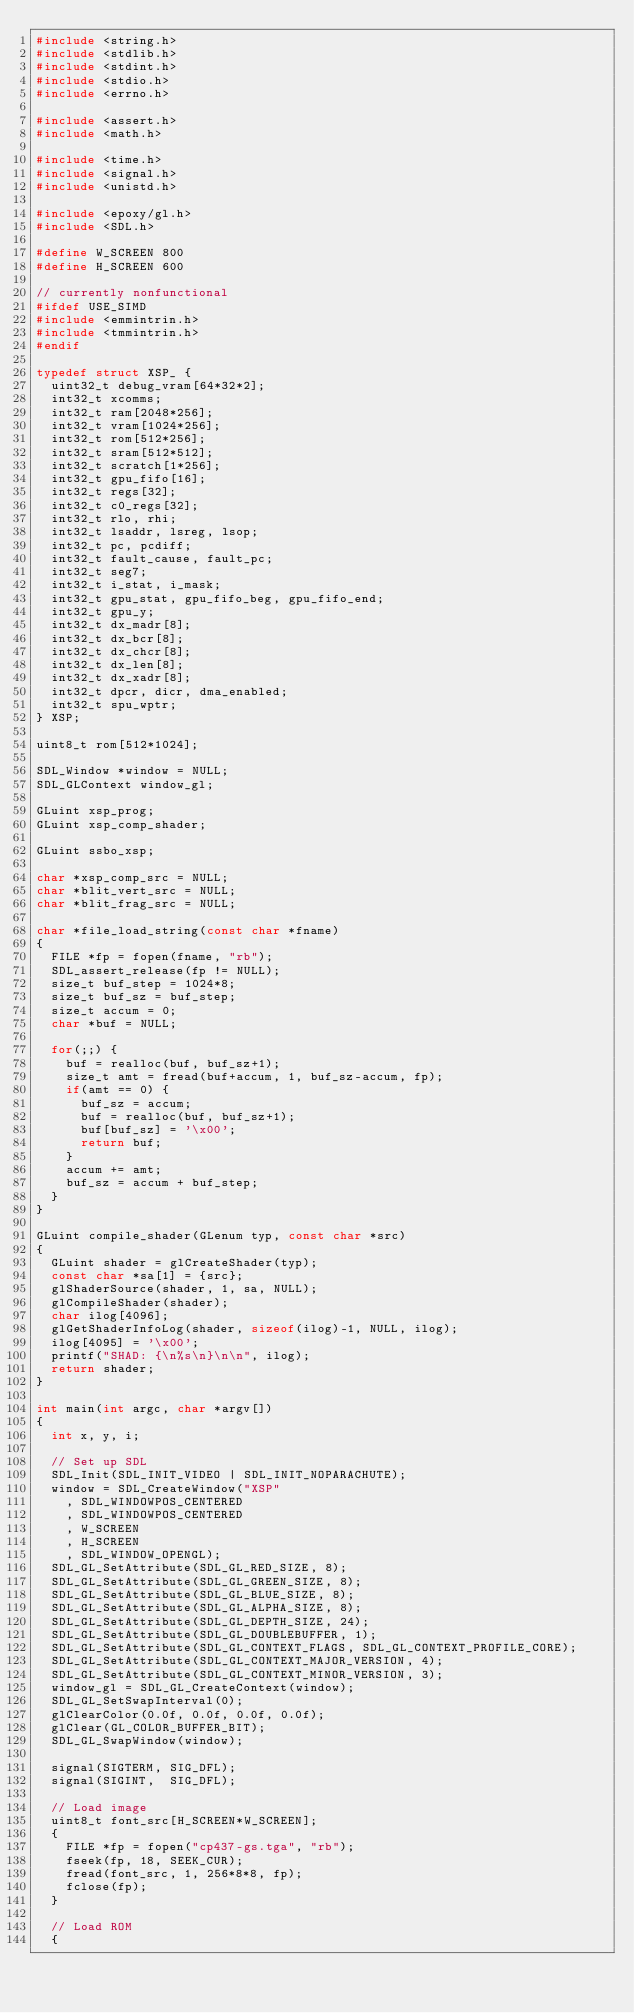Convert code to text. <code><loc_0><loc_0><loc_500><loc_500><_C_>#include <string.h>
#include <stdlib.h>
#include <stdint.h>
#include <stdio.h>
#include <errno.h>

#include <assert.h>
#include <math.h>

#include <time.h>
#include <signal.h>
#include <unistd.h>

#include <epoxy/gl.h>
#include <SDL.h>

#define W_SCREEN 800
#define H_SCREEN 600

// currently nonfunctional
#ifdef USE_SIMD
#include <emmintrin.h>
#include <tmmintrin.h>
#endif

typedef struct XSP_ {
	uint32_t debug_vram[64*32*2];
	int32_t xcomms;
	int32_t ram[2048*256];
	int32_t vram[1024*256];
	int32_t rom[512*256];
	int32_t sram[512*512];
	int32_t scratch[1*256];
	int32_t gpu_fifo[16];
	int32_t regs[32];
	int32_t c0_regs[32];
	int32_t rlo, rhi;
	int32_t lsaddr, lsreg, lsop;
	int32_t pc, pcdiff;
	int32_t fault_cause, fault_pc;
	int32_t seg7;
	int32_t i_stat, i_mask;
	int32_t gpu_stat, gpu_fifo_beg, gpu_fifo_end;
	int32_t gpu_y;
	int32_t dx_madr[8];
	int32_t dx_bcr[8];
	int32_t dx_chcr[8];
	int32_t dx_len[8];
	int32_t dx_xadr[8];
	int32_t dpcr, dicr, dma_enabled;
	int32_t spu_wptr;
} XSP;

uint8_t rom[512*1024];

SDL_Window *window = NULL;
SDL_GLContext window_gl;

GLuint xsp_prog;
GLuint xsp_comp_shader;

GLuint ssbo_xsp;

char *xsp_comp_src = NULL;
char *blit_vert_src = NULL;
char *blit_frag_src = NULL;

char *file_load_string(const char *fname)
{
	FILE *fp = fopen(fname, "rb");
	SDL_assert_release(fp != NULL);
	size_t buf_step = 1024*8;
	size_t buf_sz = buf_step;
	size_t accum = 0;
	char *buf = NULL;
	
	for(;;) {
		buf = realloc(buf, buf_sz+1);
		size_t amt = fread(buf+accum, 1, buf_sz-accum, fp);
		if(amt == 0) {
			buf_sz = accum;
			buf = realloc(buf, buf_sz+1);
			buf[buf_sz] = '\x00';
			return buf;
		}
		accum += amt;
		buf_sz = accum + buf_step;
	}
}

GLuint compile_shader(GLenum typ, const char *src)
{
	GLuint shader = glCreateShader(typ);
	const char *sa[1] = {src};
	glShaderSource(shader, 1, sa, NULL);
	glCompileShader(shader);
	char ilog[4096];
	glGetShaderInfoLog(shader, sizeof(ilog)-1, NULL, ilog);
	ilog[4095] = '\x00';
	printf("SHAD: {\n%s\n}\n\n", ilog);
	return shader;
}

int main(int argc, char *argv[])
{
	int x, y, i;

	// Set up SDL
	SDL_Init(SDL_INIT_VIDEO | SDL_INIT_NOPARACHUTE);
	window = SDL_CreateWindow("XSP"
		, SDL_WINDOWPOS_CENTERED
		, SDL_WINDOWPOS_CENTERED
		, W_SCREEN
		, H_SCREEN
		, SDL_WINDOW_OPENGL);
	SDL_GL_SetAttribute(SDL_GL_RED_SIZE, 8);
	SDL_GL_SetAttribute(SDL_GL_GREEN_SIZE, 8);
	SDL_GL_SetAttribute(SDL_GL_BLUE_SIZE, 8);
	SDL_GL_SetAttribute(SDL_GL_ALPHA_SIZE, 8);
	SDL_GL_SetAttribute(SDL_GL_DEPTH_SIZE, 24);
	SDL_GL_SetAttribute(SDL_GL_DOUBLEBUFFER, 1);
	SDL_GL_SetAttribute(SDL_GL_CONTEXT_FLAGS, SDL_GL_CONTEXT_PROFILE_CORE);
	SDL_GL_SetAttribute(SDL_GL_CONTEXT_MAJOR_VERSION, 4);
	SDL_GL_SetAttribute(SDL_GL_CONTEXT_MINOR_VERSION, 3);
	window_gl = SDL_GL_CreateContext(window);
	SDL_GL_SetSwapInterval(0);
	glClearColor(0.0f, 0.0f, 0.0f, 0.0f);
	glClear(GL_COLOR_BUFFER_BIT);
	SDL_GL_SwapWindow(window);

	signal(SIGTERM, SIG_DFL);
	signal(SIGINT,  SIG_DFL);

	// Load image
	uint8_t font_src[H_SCREEN*W_SCREEN];
	{
		FILE *fp = fopen("cp437-gs.tga", "rb");
		fseek(fp, 18, SEEK_CUR);
		fread(font_src, 1, 256*8*8, fp);
		fclose(fp);
	}

	// Load ROM
	{</code> 